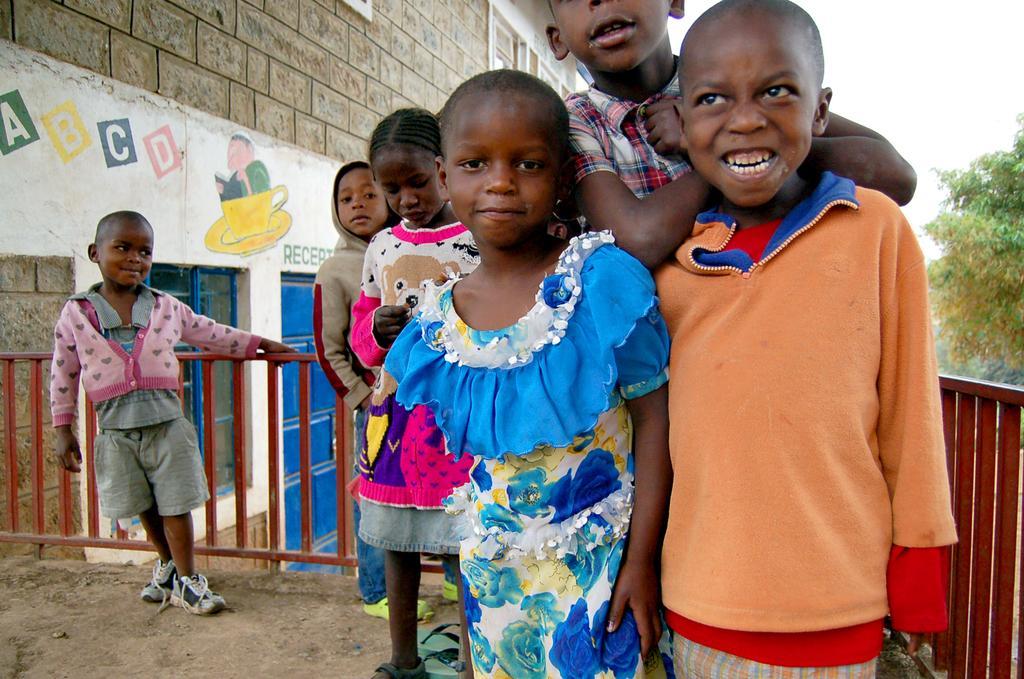Describe this image in one or two sentences. There are few kids standing and there is a fence beside them and there is a building in the left corner and there is a tree in the right corner. 